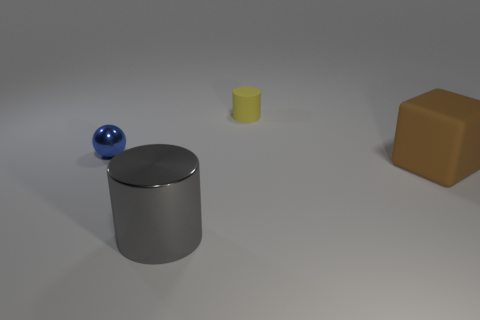There is a brown thing; is it the same size as the matte object that is behind the blue metal object? The brown object, which appears to be a cube, is not the same size as the matte cylinder behind the blue sphere. The brown cube is considerably larger in volume compared to the matte cylinder. 